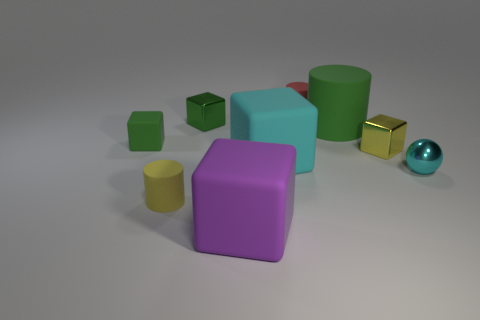Is there anything else of the same color as the large matte cylinder? Yes, there is a smaller cylinder with the same green hue as the large matte cylinder located towards the back of the scene. 